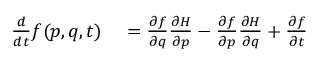<formula> <loc_0><loc_0><loc_500><loc_500>\begin{array} { r l } { { \frac { d } { d t } } f ( p , q , t ) } & = { \frac { \partial f } { \partial q } } { \frac { \partial H } { \partial p } } - { \frac { \partial f } { \partial p } } { \frac { \partial H } { \partial q } } + { \frac { \partial f } { \partial t } } } \end{array}</formula> 